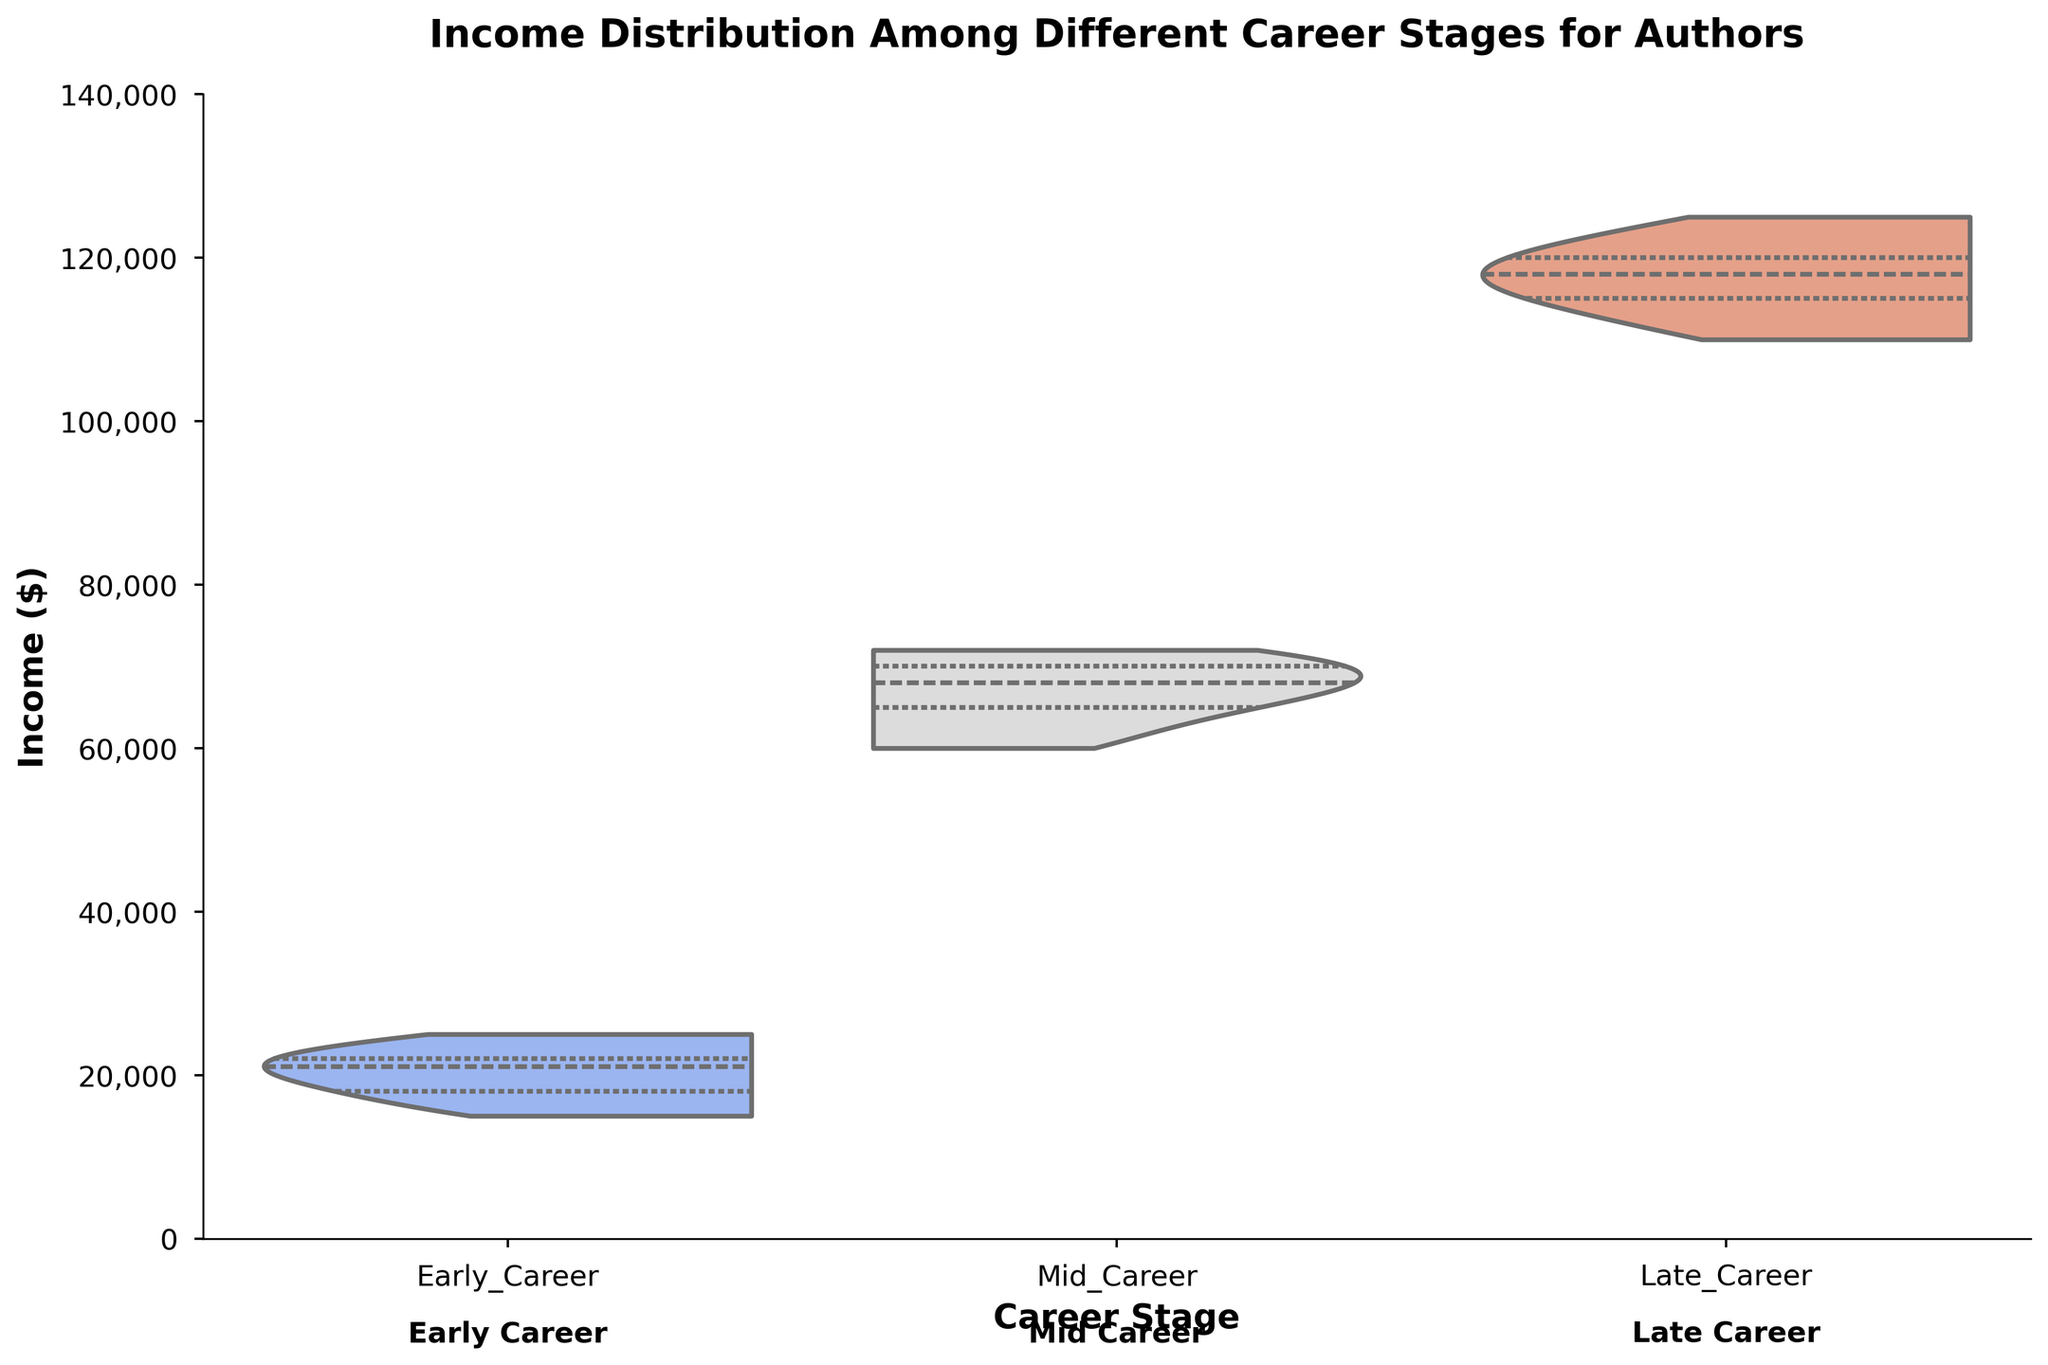What is the title of the figure? The title of the figure is written at the top of the plot and indicates the main focus of the data visualization.
Answer: Income Distribution Among Different Career Stages for Authors What does the Y-axis represent in the plot? The Y-axis represents the income in dollars for the authors. This is clear from the axis label "Income ($)" next to the Y-axis.
Answer: Income ($) How do the income distributions change from Early Career to Late Career? We need to compare the density and spread of the violin plots for each career stage. The spread and height increase significantly, indicating that authors earn more as they progress through their careers.
Answer: It increases What is the median income for authors in the Mid Career stage? The median income is represented by the white dot within the violin plot for the Mid Career stage.
Answer: Around $68,000 Which career stage has the widest range of income distribution? The width of the violin plot indicates the range/distribution of incomes. Comparing the stages, the Late Career stage has the widest distribution.
Answer: Late Career What is the approximate income range for Early Career authors? Observing the top and bottom points of the violin plot for Early Career, the income ranges from around $15,000 to $25,000.
Answer: $15,000 to $25,000 How does the interquartile range (IQR) for Mid Career compare with Late Career? The interquartile range is the width of the box inside the violin plot. Mid Career has a narrower IQR compared to Late Career.
Answer: Narrower Are there any overlapping income distributions between the stages? We look at the density overlaps between each stage's violin plots. There is some overlap between Mid Career and Late Career incomes.
Answer: Yes Which author's income is the highest, and in which stage? Observing the max density point in the Late Career stage where Suzanne Collins' name appears indicates she has the highest income.
Answer: Suzanne Collins in Late Career 